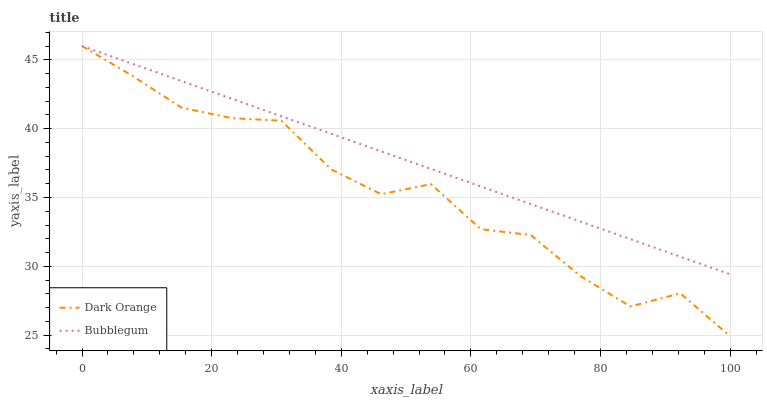Does Dark Orange have the minimum area under the curve?
Answer yes or no. Yes. Does Bubblegum have the maximum area under the curve?
Answer yes or no. Yes. Does Bubblegum have the minimum area under the curve?
Answer yes or no. No. Is Bubblegum the smoothest?
Answer yes or no. Yes. Is Dark Orange the roughest?
Answer yes or no. Yes. Is Bubblegum the roughest?
Answer yes or no. No. Does Dark Orange have the lowest value?
Answer yes or no. Yes. Does Bubblegum have the lowest value?
Answer yes or no. No. Does Bubblegum have the highest value?
Answer yes or no. Yes. Does Dark Orange intersect Bubblegum?
Answer yes or no. Yes. Is Dark Orange less than Bubblegum?
Answer yes or no. No. Is Dark Orange greater than Bubblegum?
Answer yes or no. No. 